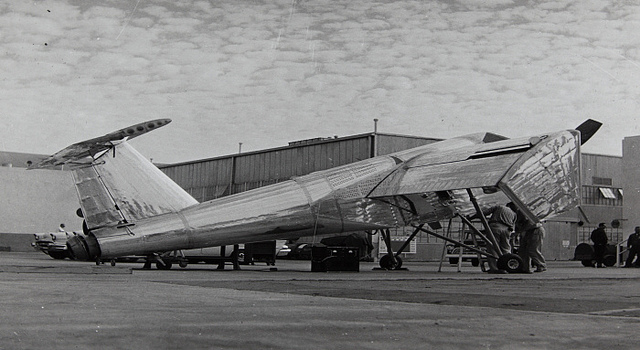<image>Who is the polite? It is ambiguous who is polite. It could be the mechanic, the man on ladder, the pilot or no one. Who is the polite? I don't know who is the polite. It can be the mechanic, the man on the ladder, or the pilot. 